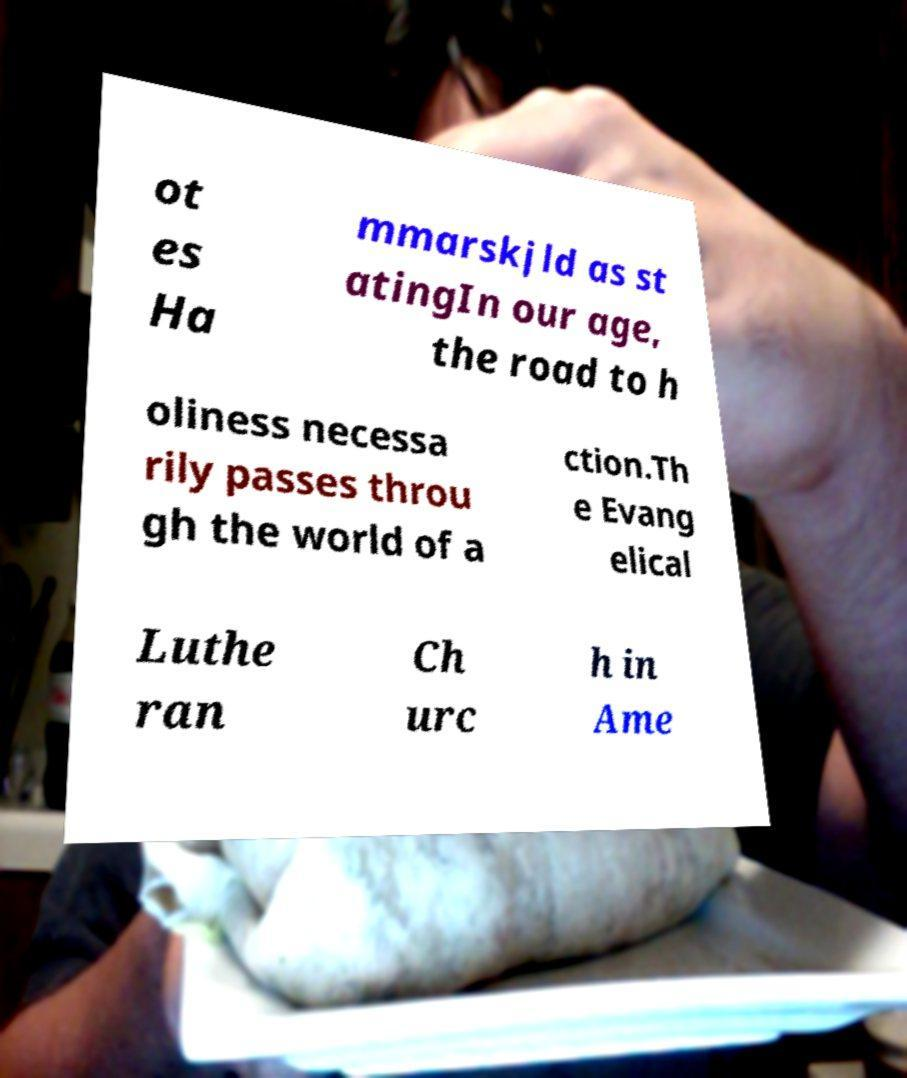For documentation purposes, I need the text within this image transcribed. Could you provide that? ot es Ha mmarskjld as st atingIn our age, the road to h oliness necessa rily passes throu gh the world of a ction.Th e Evang elical Luthe ran Ch urc h in Ame 